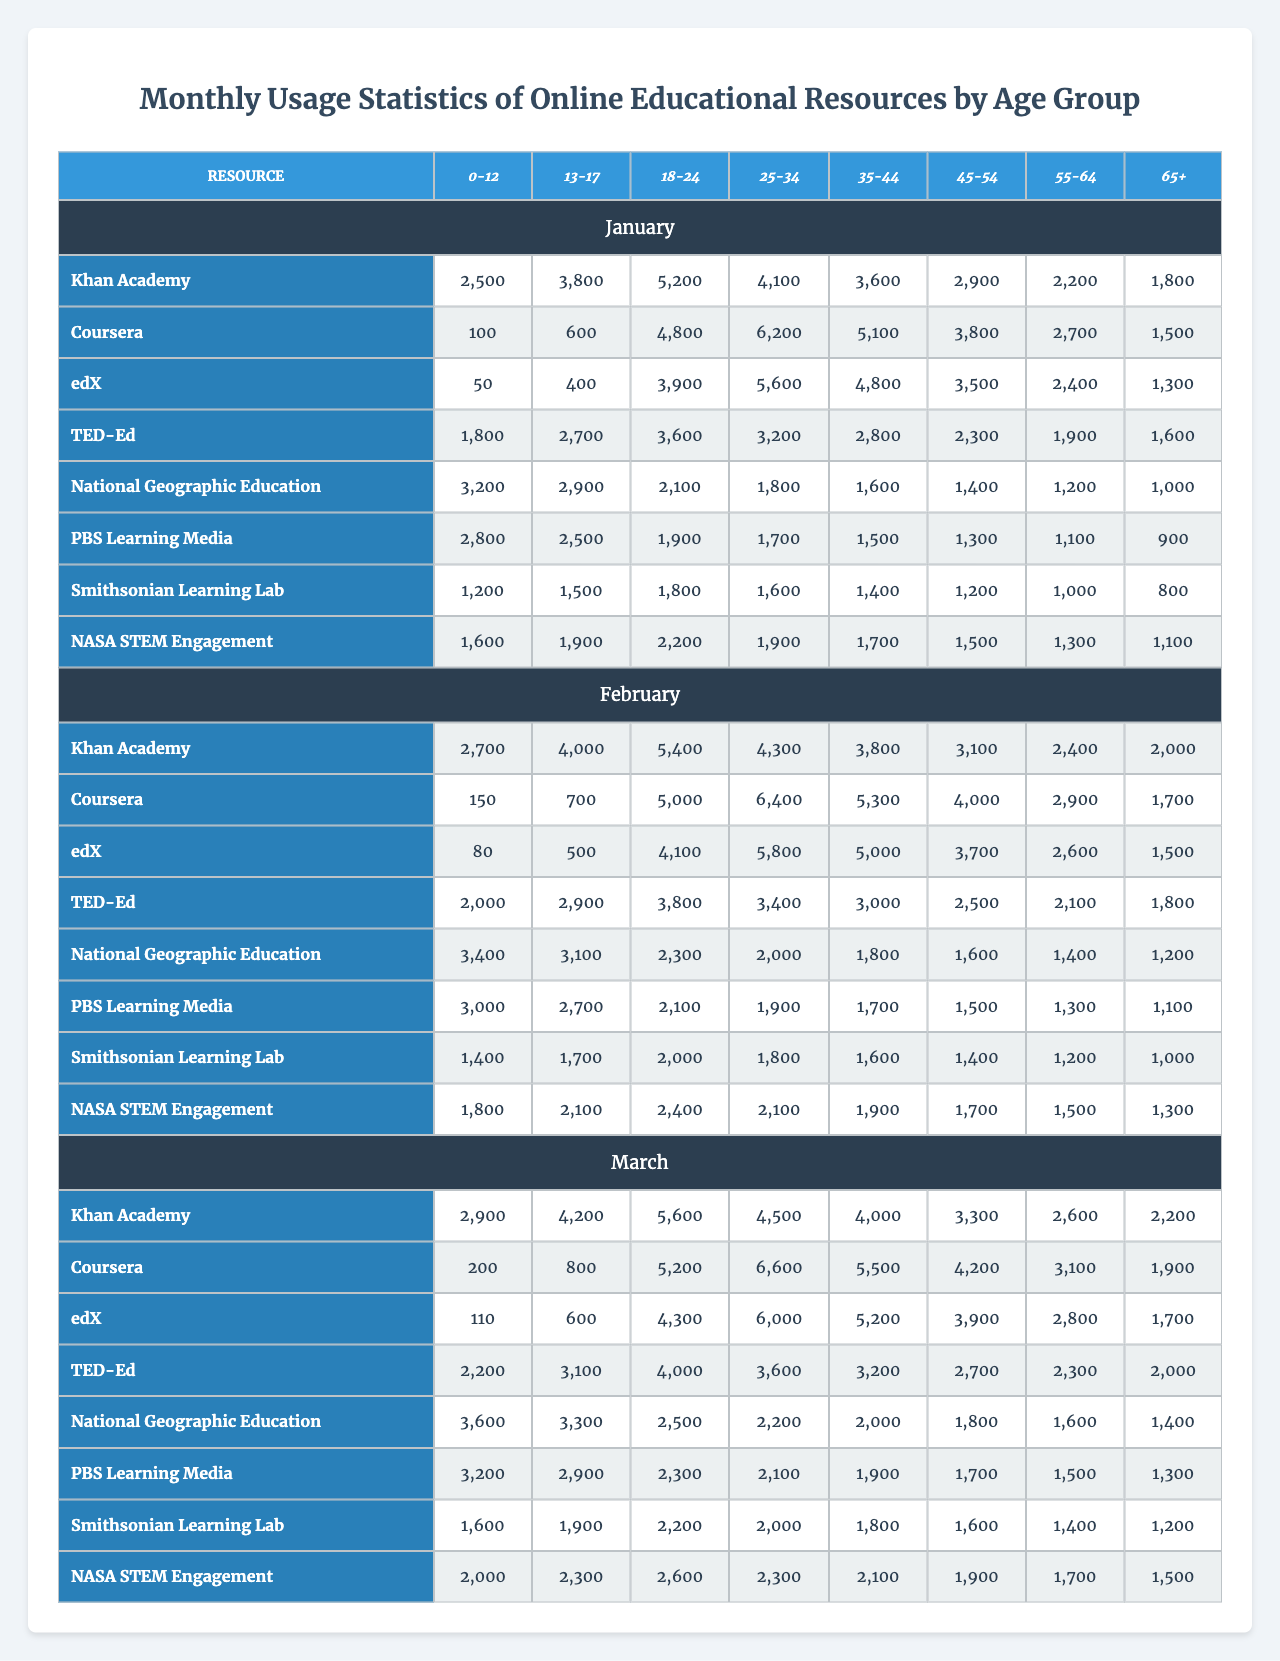What is the highest monthly usage of Khan Academy for the age group 18-24? In the January data, the usage for the age group 18-24 is 5200. In February, it is 5400, and in March, it is 5600. The highest monthly usage is therefore 5600.
Answer: 5600 What is the total monthly usage of PBS Learning Media for the age group 35-44 across the three months? For PBS Learning Media, the usage for the age group 35-44 is 1700 in January, 1900 in February, and 2100 in March. Adding them up gives 1700 + 1900 + 2100 = 5700.
Answer: 5700 Did the usage of edX by the age group 45-54 decline from January to February? In January, the usage for the age group 45-54 is 3500 and in February it is 3700. Since 3700 is greater than 3500, it did not decline.
Answer: No Which online resource had the highest usage for the age group 0-12 in March? For the age group 0-12 in March, the respective usages are: Khan Academy (2900), Coursera (200), edX (110), TED-Ed (2200), National Geographic Education (3600), PBS Learning Media (3200), Smithsonian Learning Lab (1600), and NASA STEM Engagement (2000). The highest usage is 3600 for National Geographic Education.
Answer: National Geographic Education What is the difference in monthly usage of Coursera for the age group 55-64 between February and March? For Coursera, the usage for the age group 55-64 is 4000 in February and 4200 in March. The difference is 4200 - 4000 = 200.
Answer: 200 What is the average usage of TED-Ed for the age group 13-17 across all three months? For TED-Ed, the usage for the age group 13-17 is: January (2700), February (2900), and March (3100). The total is 2700 + 2900 + 3100 = 8700. Dividing by 3 gives an average of 8700 / 3 = 2900.
Answer: 2900 Which resource had the lowest usage for the age group 65+ in January? For the age group 65+ in January, the usages are: Khan Academy (1800), Coursera (1500), edX (1300), TED-Ed (1600), National Geographic Education (1000), PBS Learning Media (900), Smithsonian Learning Lab (800), and NASA STEM Engagement (1100). The lowest usage is 800 for Smithsonian Learning Lab.
Answer: Smithsonian Learning Lab What was the total usage of NASA STEM Engagement for age group 0-12 over the three months? The usage for NASA STEM Engagement for age group 0-12 over the three months is: January (1600), February (1800), and March (2000). Adding these gives 1600 + 1800 + 2000 = 5400.
Answer: 5400 Is it true that more than 5000 users engaged with Coursera by the age group 25-34 in March? The usage for Coursera by the age group 25-34 in March is 6600, which is greater than 5000. Therefore, it is true.
Answer: Yes Which age group had the most consistent usage for PBS Learning Media across the three months? To find the most consistent age group for PBS Learning Media, we look at the usage: 1700 (35-44), 1900 (35-44), and 2100 (35-44). The differences are 200 for the 35-44 age group. Checking the usage for other age groups proves they fluctuate more. This age group is the most consistent.
Answer: 35-44 